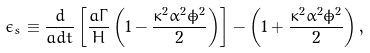<formula> <loc_0><loc_0><loc_500><loc_500>\epsilon _ { s } \equiv \frac { d } { a d t } \left [ \frac { a \Gamma } { H } \left ( 1 - \frac { \kappa ^ { 2 } \alpha ^ { 2 } \dot { \phi } ^ { 2 } } { 2 } \right ) \right ] - \left ( 1 + \frac { \kappa ^ { 2 } \alpha ^ { 2 } \dot { \phi } ^ { 2 } } { 2 } \right ) ,</formula> 